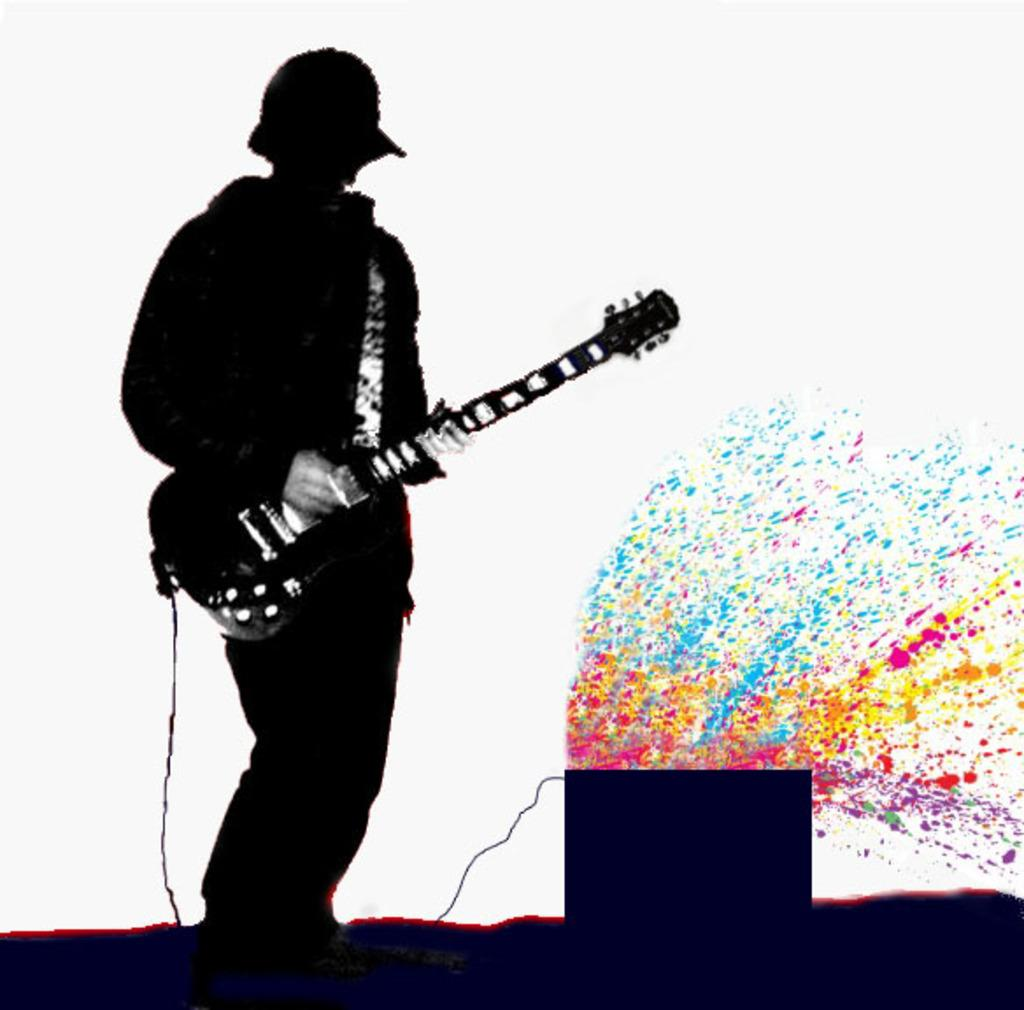What is the main subject of the image? The main subject of the image is a man. What is the man holding in the image? The man is holding a guitar. What type of quince can be seen in the man's hand in the image? There is no quince present in the image; the man is holding a guitar. What page is the man reading from in the image? There is no book or page visible in the image; the man is holding a guitar. 